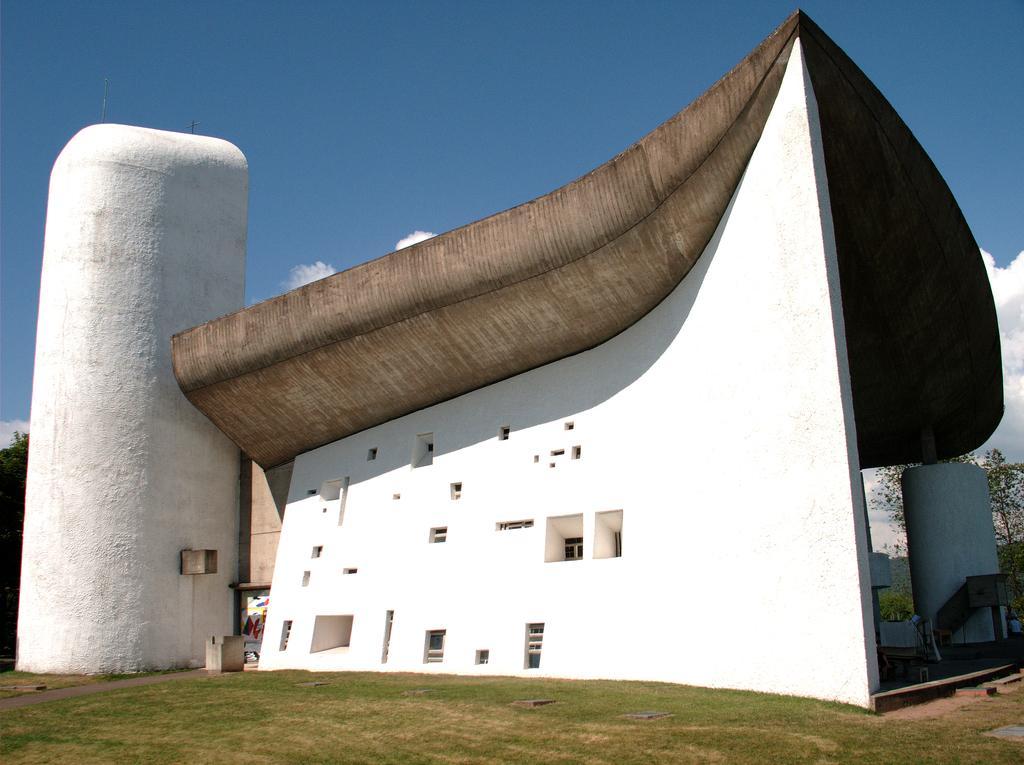Describe this image in one or two sentences. This is grass and there is a building. Here we can see trees. In the background there is sky with clouds. 